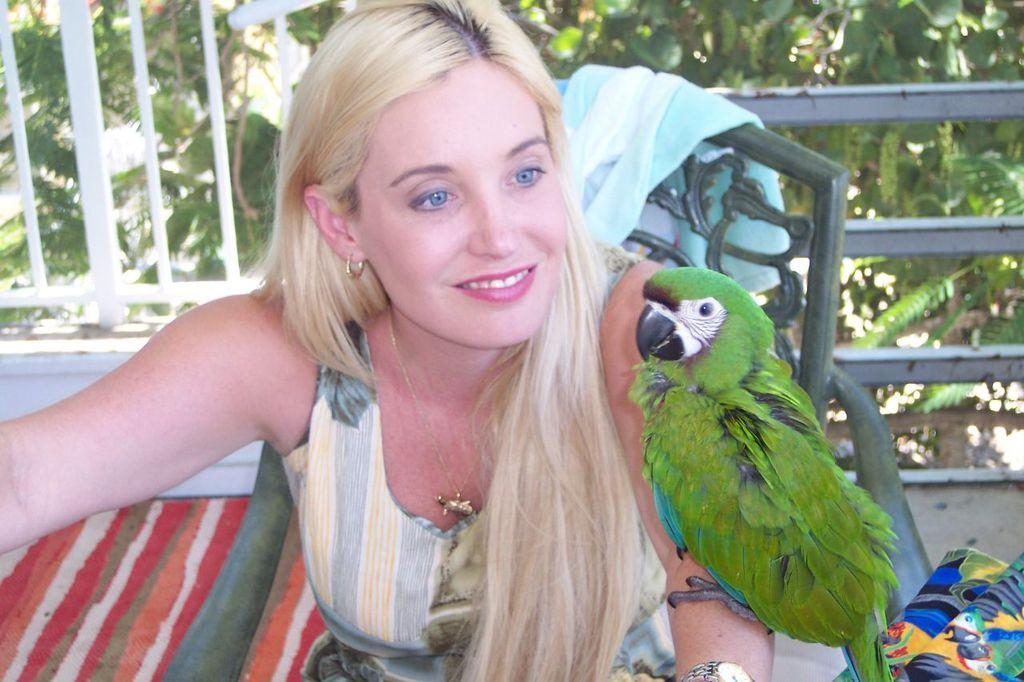What is the woman in the image doing? The woman is sitting on a chair in the image. What is on the woman's hand in the image? There is a bird on the woman's hand in the image. What can be seen in the background of the image? There is railing and trees visible in the background of the image. What type of trade is being conducted between the woman and the bird in the image? There is no indication of any trade being conducted between the woman and the bird in the image. 